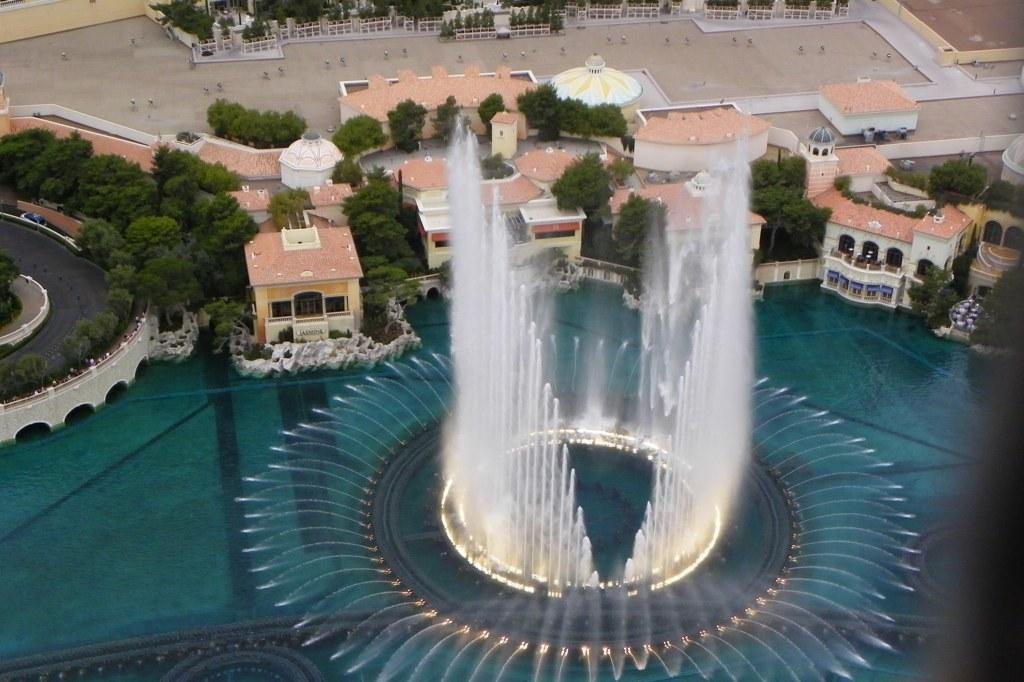What type of view is shown in the image? The image is an aerial view. What is one specific feature visible from this perspective? There is a water fountain in the image. What type of structures can be seen in the image? There are houses in the image. What type of transportation infrastructure is visible? There is a road in the image. What type of natural elements are present in the image? There are trees in the image. Where can the list of ingredients for the water fountain be found in the image? There is no list of ingredients for the water fountain present in the image. 